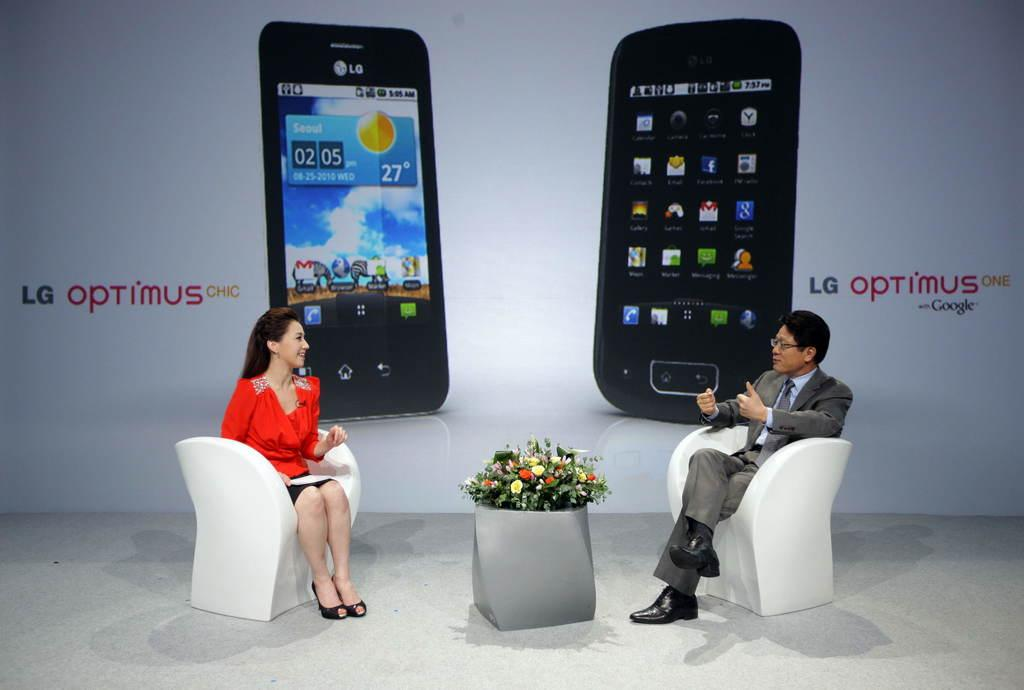<image>
Describe the image concisely. A man and woman sitting in front of an ad for a cell phone. 